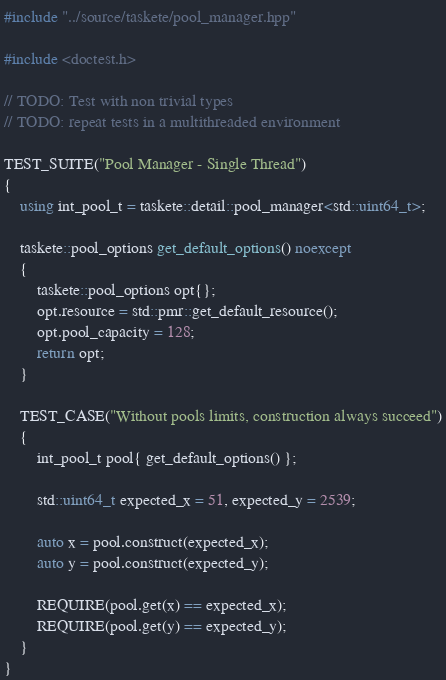Convert code to text. <code><loc_0><loc_0><loc_500><loc_500><_C++_>#include "../source/taskete/pool_manager.hpp"

#include <doctest.h>

// TODO: Test with non trivial types
// TODO: repeat tests in a multithreaded environment

TEST_SUITE("Pool Manager - Single Thread")
{
    using int_pool_t = taskete::detail::pool_manager<std::uint64_t>;

    taskete::pool_options get_default_options() noexcept
    {
        taskete::pool_options opt{};
        opt.resource = std::pmr::get_default_resource();
        opt.pool_capacity = 128;
        return opt;
    }

    TEST_CASE("Without pools limits, construction always succeed")
    {
        int_pool_t pool{ get_default_options() };

        std::uint64_t expected_x = 51, expected_y = 2539;

        auto x = pool.construct(expected_x);
        auto y = pool.construct(expected_y);

        REQUIRE(pool.get(x) == expected_x);
        REQUIRE(pool.get(y) == expected_y);
    }
}</code> 